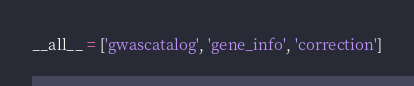<code> <loc_0><loc_0><loc_500><loc_500><_Python_>__all__ = ['gwascatalog', 'gene_info', 'correction']
</code> 